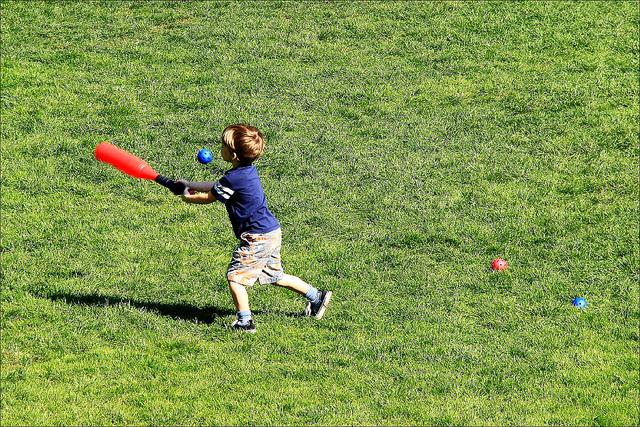How many people are there?
Quick response, please. 1. Is this a professional ball player?
Answer briefly. No. What color is the bat?
Give a very brief answer. Red. What color is the ball?
Write a very short answer. Blue. How many stripes are on the boys sleeve?
Concise answer only. 2. What sport is being played?
Be succinct. Baseball. 